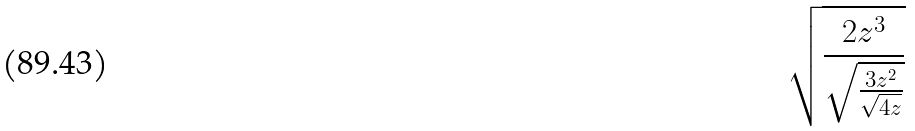<formula> <loc_0><loc_0><loc_500><loc_500>\sqrt { \frac { 2 z ^ { 3 } } { \sqrt { \frac { 3 z ^ { 2 } } { \sqrt { 4 z } } } } }</formula> 